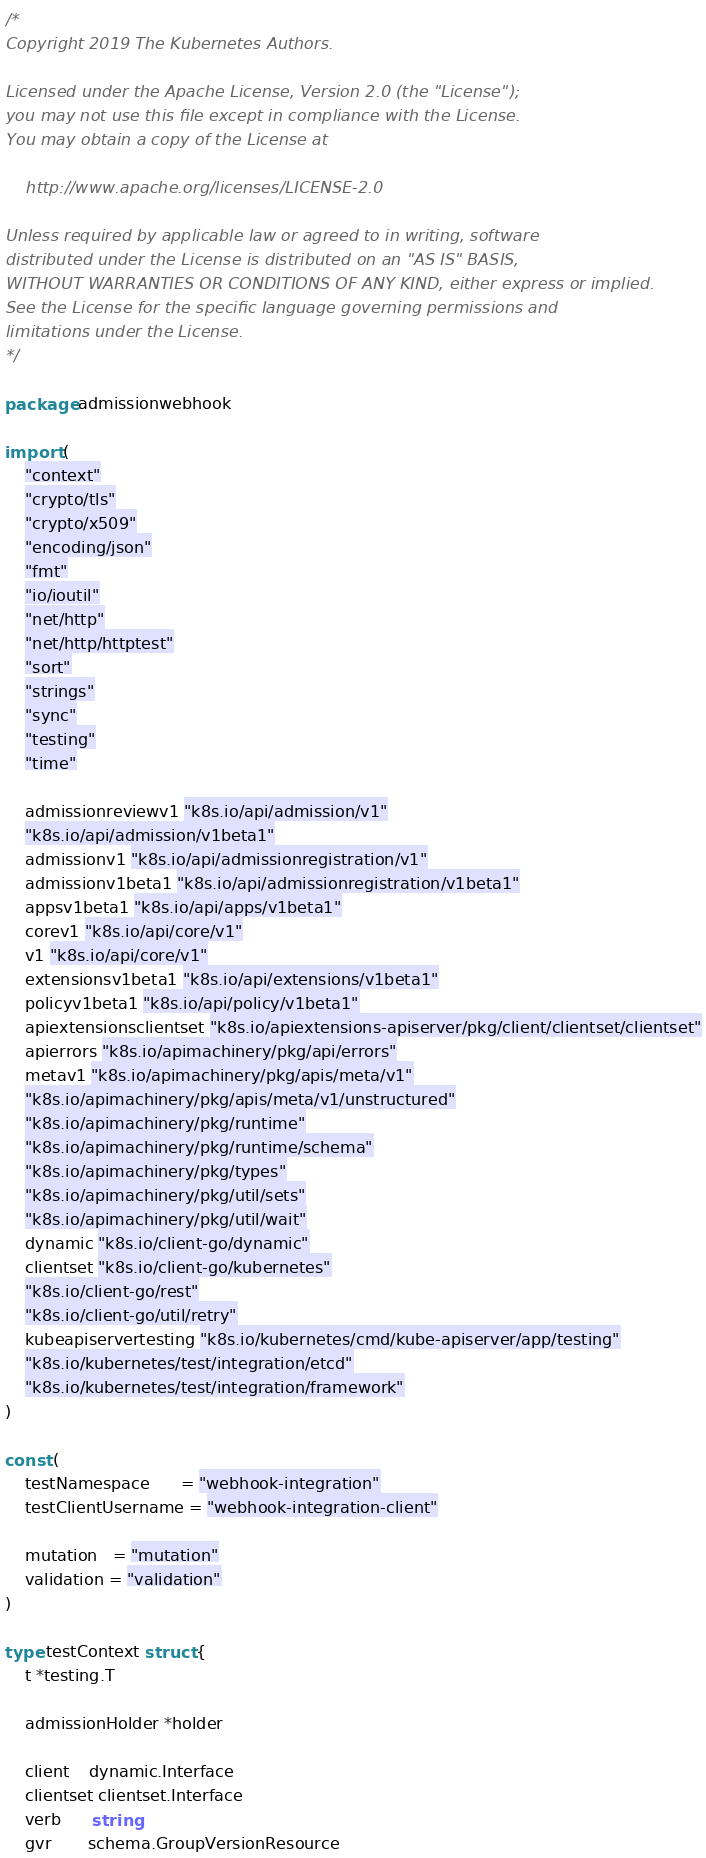<code> <loc_0><loc_0><loc_500><loc_500><_Go_>/*
Copyright 2019 The Kubernetes Authors.

Licensed under the Apache License, Version 2.0 (the "License");
you may not use this file except in compliance with the License.
You may obtain a copy of the License at

    http://www.apache.org/licenses/LICENSE-2.0

Unless required by applicable law or agreed to in writing, software
distributed under the License is distributed on an "AS IS" BASIS,
WITHOUT WARRANTIES OR CONDITIONS OF ANY KIND, either express or implied.
See the License for the specific language governing permissions and
limitations under the License.
*/

package admissionwebhook

import (
	"context"
	"crypto/tls"
	"crypto/x509"
	"encoding/json"
	"fmt"
	"io/ioutil"
	"net/http"
	"net/http/httptest"
	"sort"
	"strings"
	"sync"
	"testing"
	"time"

	admissionreviewv1 "k8s.io/api/admission/v1"
	"k8s.io/api/admission/v1beta1"
	admissionv1 "k8s.io/api/admissionregistration/v1"
	admissionv1beta1 "k8s.io/api/admissionregistration/v1beta1"
	appsv1beta1 "k8s.io/api/apps/v1beta1"
	corev1 "k8s.io/api/core/v1"
	v1 "k8s.io/api/core/v1"
	extensionsv1beta1 "k8s.io/api/extensions/v1beta1"
	policyv1beta1 "k8s.io/api/policy/v1beta1"
	apiextensionsclientset "k8s.io/apiextensions-apiserver/pkg/client/clientset/clientset"
	apierrors "k8s.io/apimachinery/pkg/api/errors"
	metav1 "k8s.io/apimachinery/pkg/apis/meta/v1"
	"k8s.io/apimachinery/pkg/apis/meta/v1/unstructured"
	"k8s.io/apimachinery/pkg/runtime"
	"k8s.io/apimachinery/pkg/runtime/schema"
	"k8s.io/apimachinery/pkg/types"
	"k8s.io/apimachinery/pkg/util/sets"
	"k8s.io/apimachinery/pkg/util/wait"
	dynamic "k8s.io/client-go/dynamic"
	clientset "k8s.io/client-go/kubernetes"
	"k8s.io/client-go/rest"
	"k8s.io/client-go/util/retry"
	kubeapiservertesting "k8s.io/kubernetes/cmd/kube-apiserver/app/testing"
	"k8s.io/kubernetes/test/integration/etcd"
	"k8s.io/kubernetes/test/integration/framework"
)

const (
	testNamespace      = "webhook-integration"
	testClientUsername = "webhook-integration-client"

	mutation   = "mutation"
	validation = "validation"
)

type testContext struct {
	t *testing.T

	admissionHolder *holder

	client    dynamic.Interface
	clientset clientset.Interface
	verb      string
	gvr       schema.GroupVersionResource</code> 